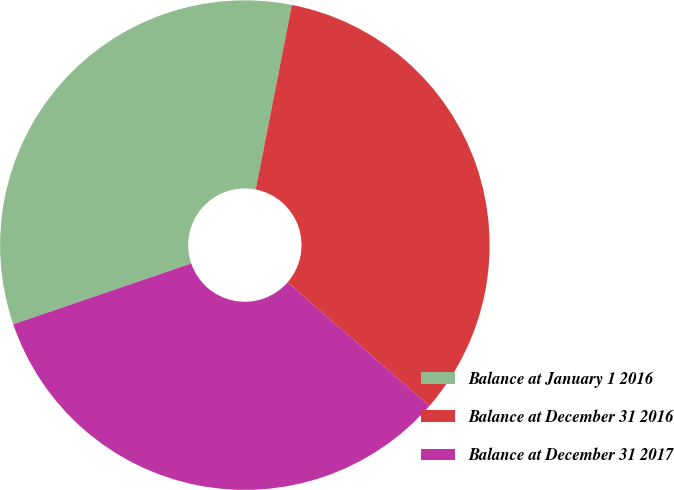Convert chart. <chart><loc_0><loc_0><loc_500><loc_500><pie_chart><fcel>Balance at January 1 2016<fcel>Balance at December 31 2016<fcel>Balance at December 31 2017<nl><fcel>33.32%<fcel>33.33%<fcel>33.35%<nl></chart> 